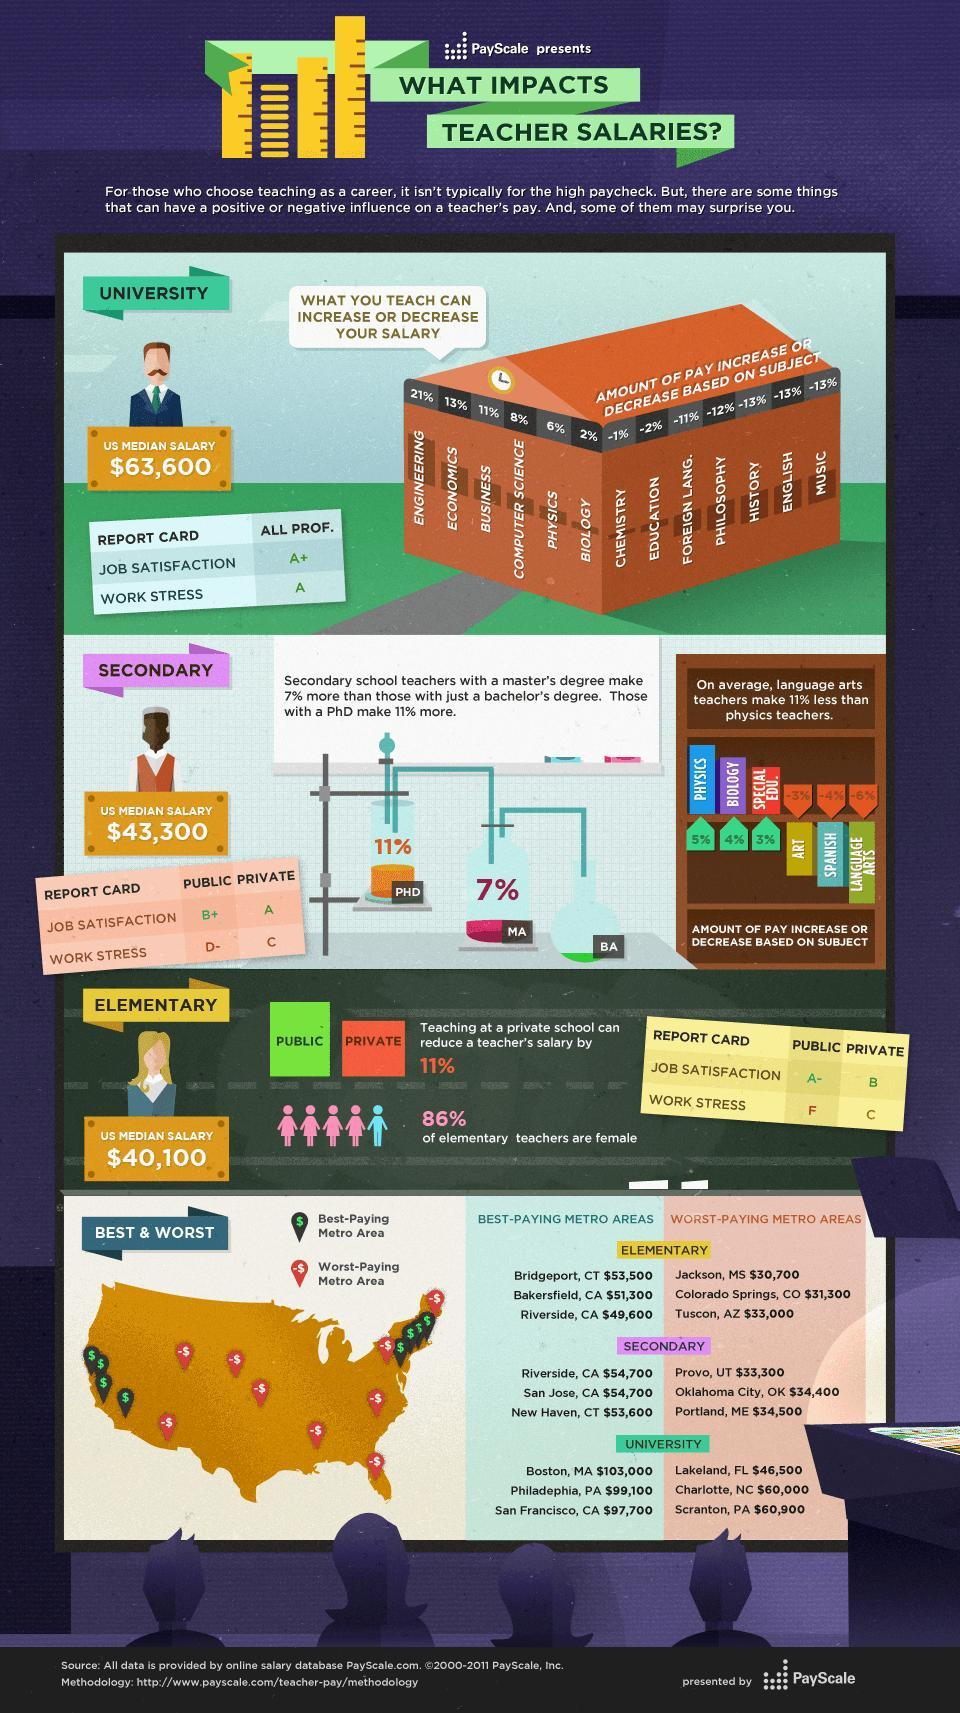Calculate the average lowest pay offered in the secondary schools located metro areas in USD?
Answer the question with a short phrase. 34,066.66 Which teachers earn a higher percentage of pay in secondary schools? Physics, Biology, Special Edu. Which metropolitan region pays the second highest amount for elementary school teachers? Bakersfield, CA Which subjects have a 13% decrease in pay ? History, English, Music Which subject offers the second highest pay in percentage? Economics What is the work stress grade in private secondary schools, A, C, or F? C What is the average best pay offered by the universities located in metro areas in USDS? 99,933.33 Which state in the US has the most number of top paid elementary and secondary schools? California What is the percentage increase in salary for business teachers, 11%, -11%, or 13%? 11% What is the job satisfaction grade in public elementary schools, A+, B+, or A-? A- 